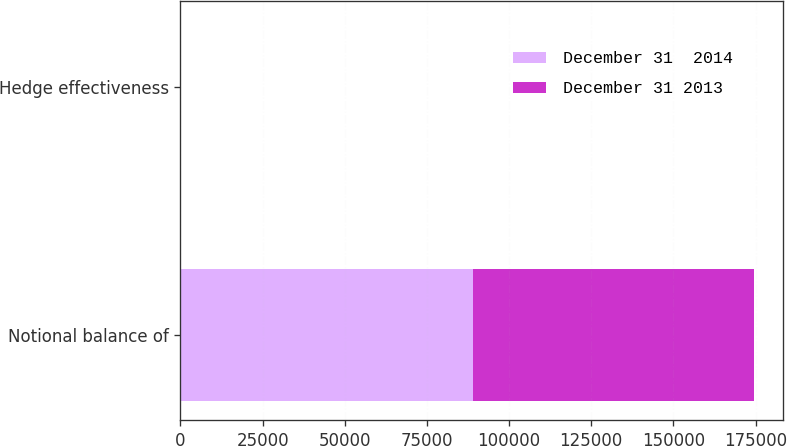Convert chart. <chart><loc_0><loc_0><loc_500><loc_500><stacked_bar_chart><ecel><fcel>Notional balance of<fcel>Hedge effectiveness<nl><fcel>December 31  2014<fcel>88969<fcel>100<nl><fcel>December 31 2013<fcel>85627<fcel>100<nl></chart> 